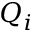<formula> <loc_0><loc_0><loc_500><loc_500>Q _ { i }</formula> 